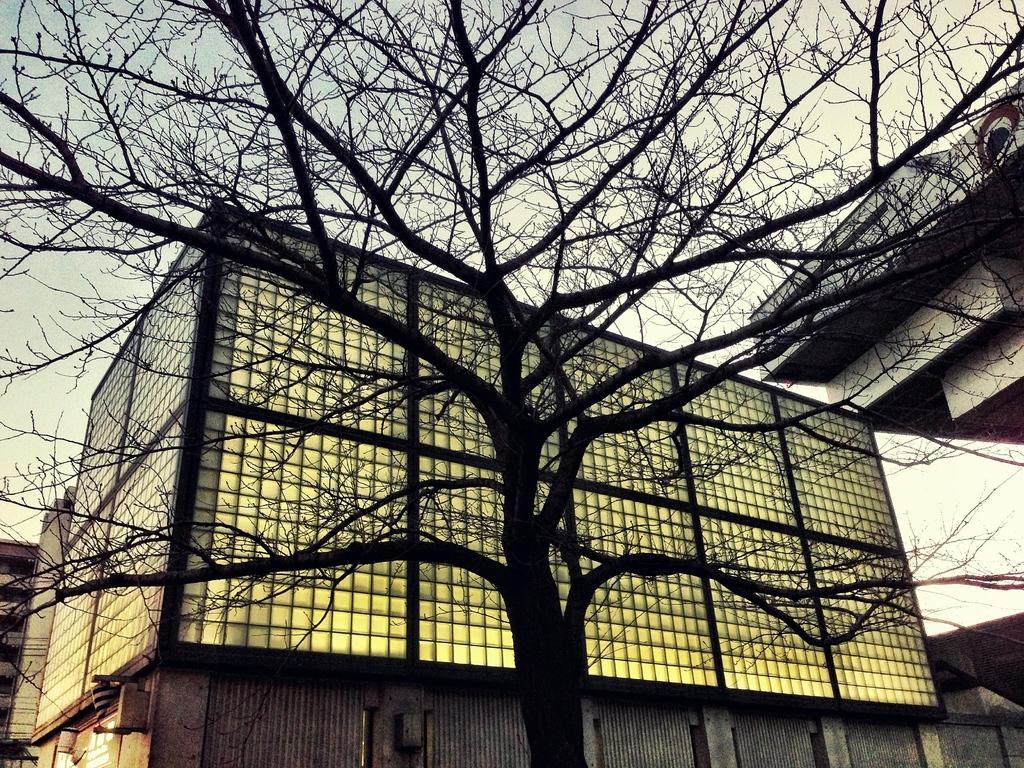In one or two sentences, can you explain what this image depicts? In front of the picture, we see a tree. Behind that, we see a building which has the glass windows. On the left side, we see the buildings. On the right side, we see a building in grey color. In the background, we see the sky. 